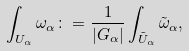<formula> <loc_0><loc_0><loc_500><loc_500>\int _ { U _ { \alpha } } \omega _ { \alpha } \colon = \frac { 1 } { | G _ { \alpha } | } \int _ { \tilde { U } _ { \alpha } } \tilde { \omega } _ { \alpha } ,</formula> 